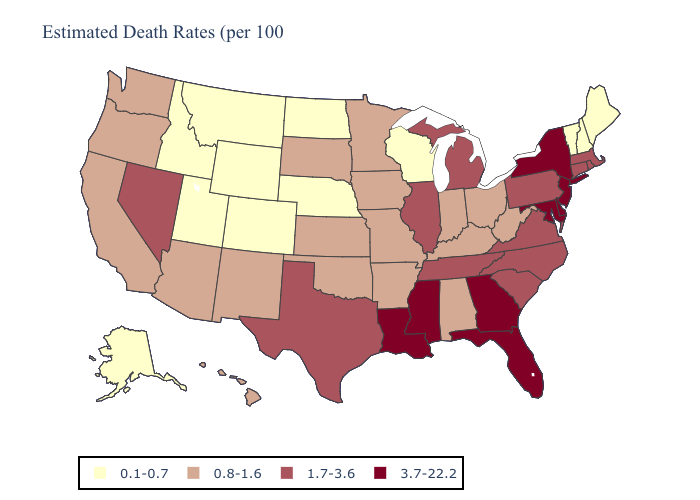What is the lowest value in states that border Washington?
Be succinct. 0.1-0.7. Which states have the highest value in the USA?
Write a very short answer. Delaware, Florida, Georgia, Louisiana, Maryland, Mississippi, New Jersey, New York. Does Kentucky have the same value as New Jersey?
Short answer required. No. Name the states that have a value in the range 1.7-3.6?
Write a very short answer. Connecticut, Illinois, Massachusetts, Michigan, Nevada, North Carolina, Pennsylvania, Rhode Island, South Carolina, Tennessee, Texas, Virginia. Among the states that border Nebraska , does Colorado have the lowest value?
Answer briefly. Yes. Name the states that have a value in the range 1.7-3.6?
Be succinct. Connecticut, Illinois, Massachusetts, Michigan, Nevada, North Carolina, Pennsylvania, Rhode Island, South Carolina, Tennessee, Texas, Virginia. Name the states that have a value in the range 1.7-3.6?
Concise answer only. Connecticut, Illinois, Massachusetts, Michigan, Nevada, North Carolina, Pennsylvania, Rhode Island, South Carolina, Tennessee, Texas, Virginia. Among the states that border New Jersey , which have the highest value?
Quick response, please. Delaware, New York. What is the highest value in states that border Wisconsin?
Be succinct. 1.7-3.6. What is the value of Delaware?
Write a very short answer. 3.7-22.2. What is the highest value in the USA?
Give a very brief answer. 3.7-22.2. Name the states that have a value in the range 3.7-22.2?
Short answer required. Delaware, Florida, Georgia, Louisiana, Maryland, Mississippi, New Jersey, New York. What is the value of Nebraska?
Concise answer only. 0.1-0.7. Name the states that have a value in the range 0.8-1.6?
Be succinct. Alabama, Arizona, Arkansas, California, Hawaii, Indiana, Iowa, Kansas, Kentucky, Minnesota, Missouri, New Mexico, Ohio, Oklahoma, Oregon, South Dakota, Washington, West Virginia. Name the states that have a value in the range 1.7-3.6?
Keep it brief. Connecticut, Illinois, Massachusetts, Michigan, Nevada, North Carolina, Pennsylvania, Rhode Island, South Carolina, Tennessee, Texas, Virginia. 